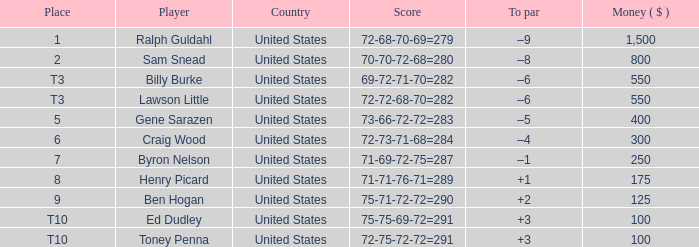In which nation is there an award valued at less than $250 involving the participant henry picard? United States. 